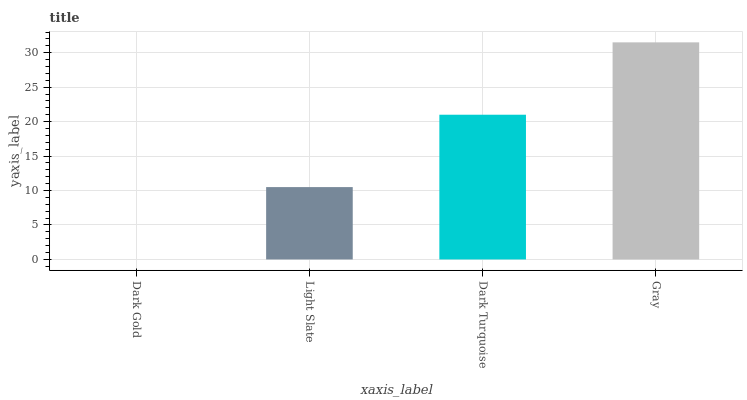Is Dark Gold the minimum?
Answer yes or no. Yes. Is Gray the maximum?
Answer yes or no. Yes. Is Light Slate the minimum?
Answer yes or no. No. Is Light Slate the maximum?
Answer yes or no. No. Is Light Slate greater than Dark Gold?
Answer yes or no. Yes. Is Dark Gold less than Light Slate?
Answer yes or no. Yes. Is Dark Gold greater than Light Slate?
Answer yes or no. No. Is Light Slate less than Dark Gold?
Answer yes or no. No. Is Dark Turquoise the high median?
Answer yes or no. Yes. Is Light Slate the low median?
Answer yes or no. Yes. Is Dark Gold the high median?
Answer yes or no. No. Is Dark Turquoise the low median?
Answer yes or no. No. 